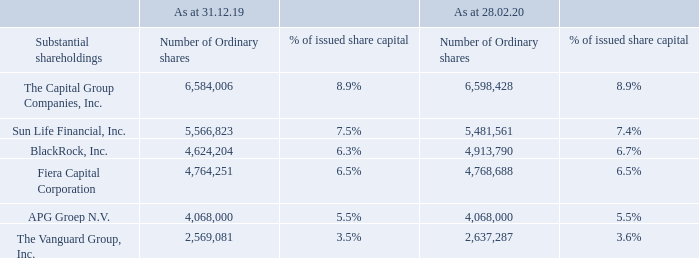Substantial shareholdings
The voting rights in the table below have been determined in accordance with the requirements of the UK Listing Authority’s Disclosure and Transparency Rules DTR 5, and represent 3% or more of the voting rights attached to issued shares in the Company as at 28th February 2020 and 31st December 2019. There are no Controlling Founder Shareholders.
How were the voting rights in the table determined? In accordance with the requirements of the uk listing authority’s disclosure and transparency rules dtr 5. What do the voting rights in the table represent? 3% or more of the voting rights attached to issued shares in the company as at 28th february 2020 and 31st december 2019. What are the companies under substantial shareholdings in the table? The capital group companies, inc., sun life financial, inc., blackrock, inc., fiera capital corporation, apg groep n.v., the vanguard group, inc. Which company has the largest % of issued share capital as at 28.02.20? 8.9%>7.4%>6.7%>6.5%>5.5%>3.6%
Answer: the capital group companies, inc. What was the change in the number of ordinary shares for BlackRock, Inc. in 2020 from 2019? 4,913,790-4,624,204
Answer: 289586. What was the percentage change in the number of ordinary shares for BlackRock, Inc. in 2020 from 2019?
Answer scale should be: percent. (4,913,790-4,624,204)/4,624,204
Answer: 6.26. 